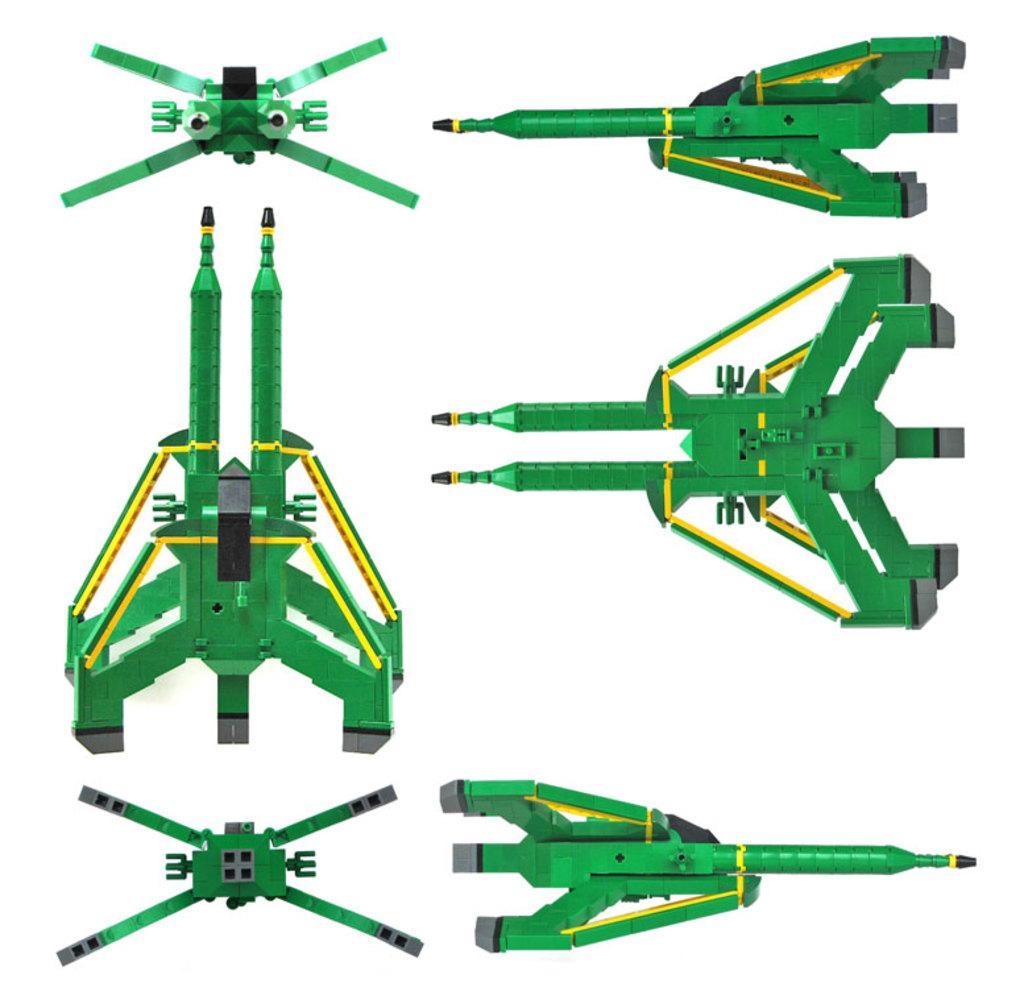In one or two sentences, can you explain what this image depicts? In this image I can see the images of missiles, rockets and some other objects. These are in green color. The background is white color. 